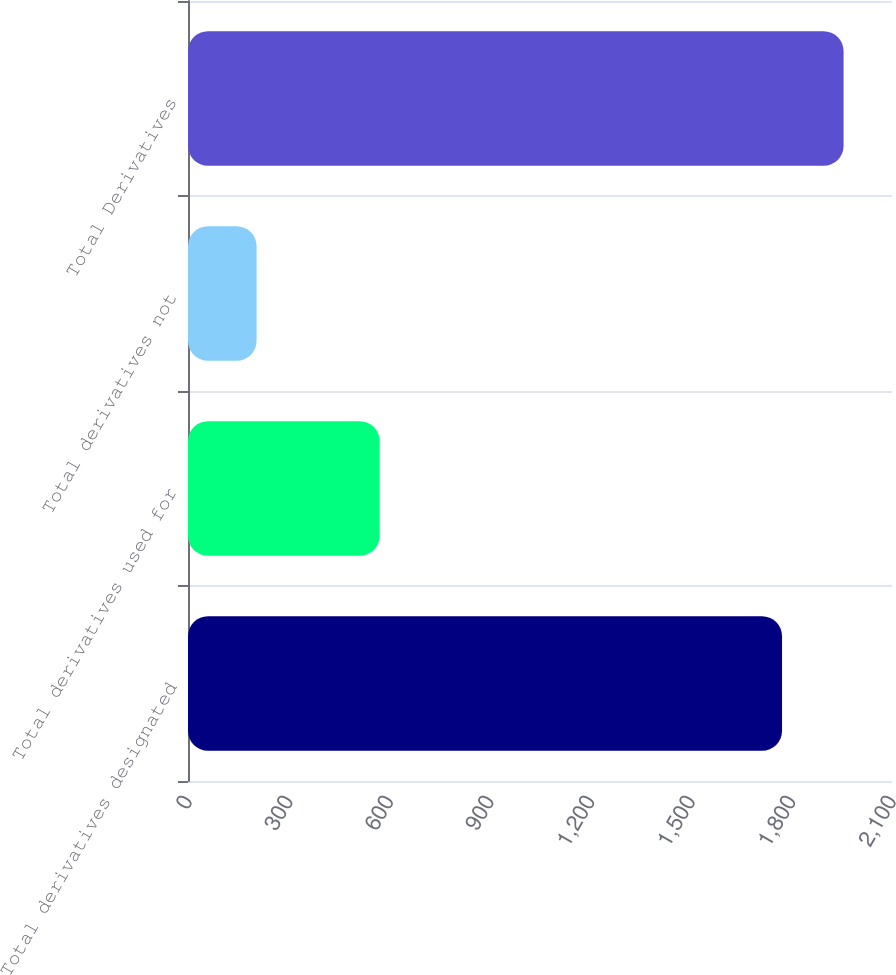Convert chart to OTSL. <chart><loc_0><loc_0><loc_500><loc_500><bar_chart><fcel>Total derivatives designated<fcel>Total derivatives used for<fcel>Total derivatives not<fcel>Total Derivatives<nl><fcel>1772<fcel>571.8<fcel>204.6<fcel>1955.6<nl></chart> 